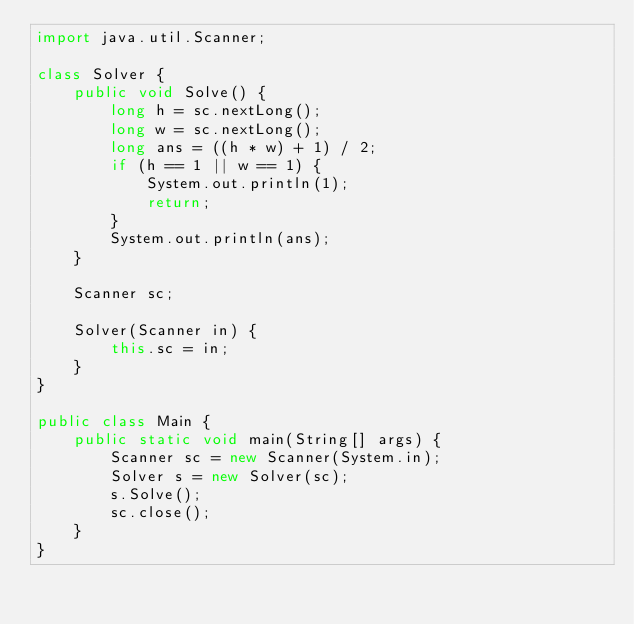<code> <loc_0><loc_0><loc_500><loc_500><_Java_>import java.util.Scanner;

class Solver {
    public void Solve() {
        long h = sc.nextLong();
        long w = sc.nextLong();
        long ans = ((h * w) + 1) / 2;
        if (h == 1 || w == 1) {
            System.out.println(1);
            return;
        }
        System.out.println(ans);
    }

    Scanner sc;

    Solver(Scanner in) {
        this.sc = in;
    }
}

public class Main {
    public static void main(String[] args) {
        Scanner sc = new Scanner(System.in);
        Solver s = new Solver(sc);
        s.Solve();
        sc.close();
    }
}
</code> 